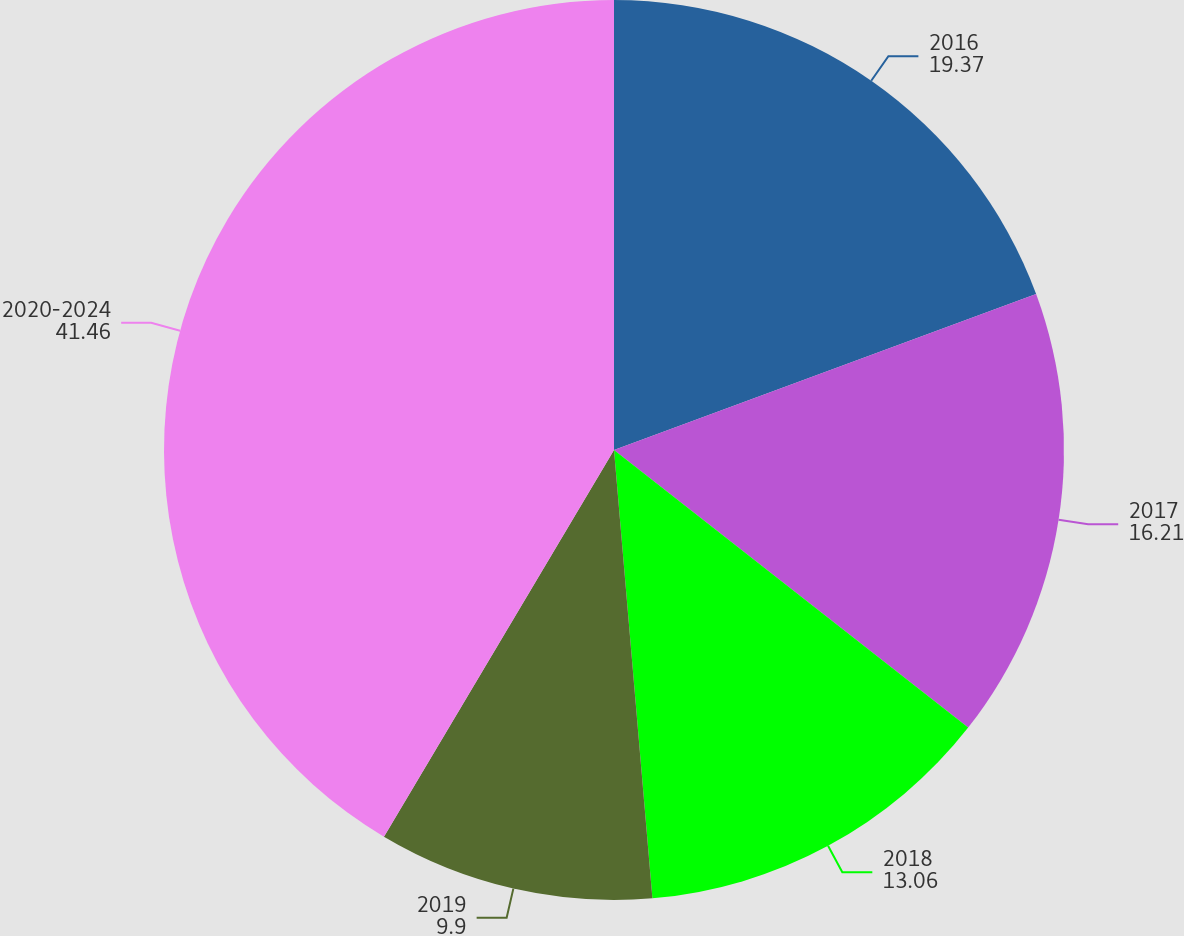Convert chart to OTSL. <chart><loc_0><loc_0><loc_500><loc_500><pie_chart><fcel>2016<fcel>2017<fcel>2018<fcel>2019<fcel>2020-2024<nl><fcel>19.37%<fcel>16.21%<fcel>13.06%<fcel>9.9%<fcel>41.46%<nl></chart> 